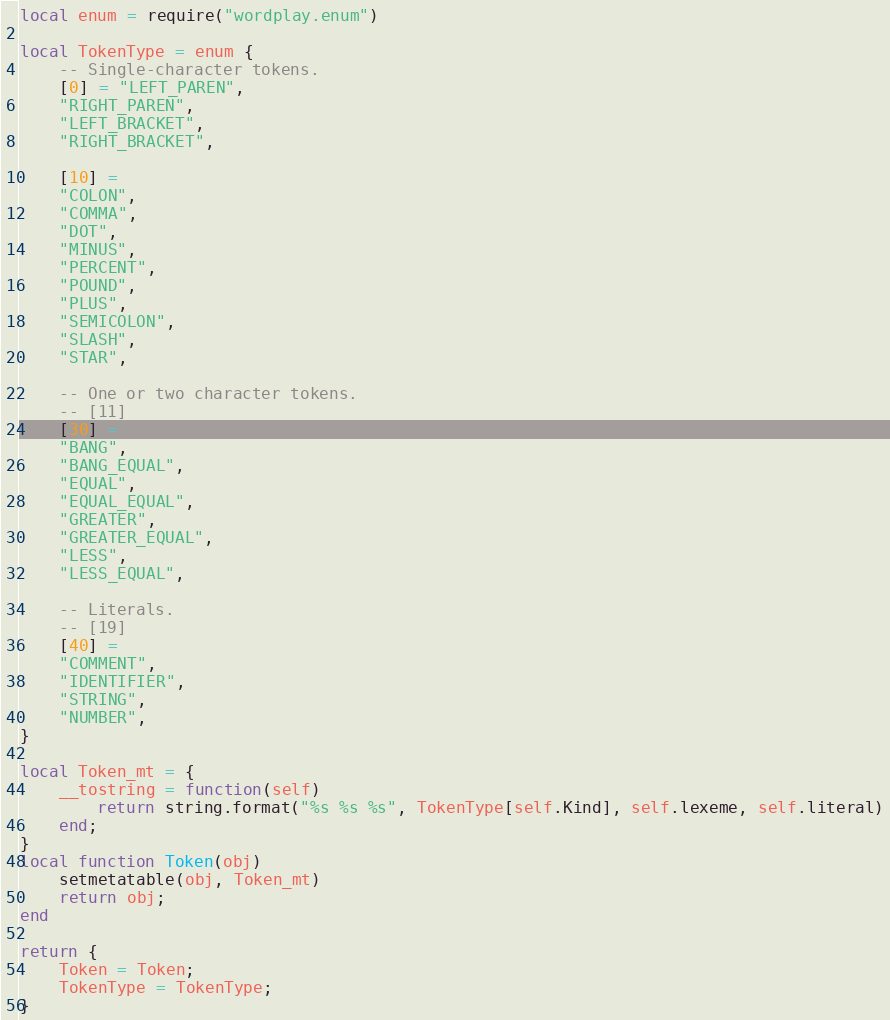Convert code to text. <code><loc_0><loc_0><loc_500><loc_500><_Lua_>local enum = require("wordplay.enum")

local TokenType = enum {                                   
    -- Single-character tokens.                      
    [0] = "LEFT_PAREN", 
    "RIGHT_PAREN", 
    "LEFT_BRACKET", 
    "RIGHT_BRACKET",
    
    [10] =
    "COLON",
    "COMMA", 
    "DOT", 
    "MINUS", 
    "PERCENT",
    "POUND",
    "PLUS", 
    "SEMICOLON", 
    "SLASH", 
    "STAR", 

    -- One or two character tokens.
    -- [11]
    [30] = 
    "BANG", 
    "BANG_EQUAL",                                
    "EQUAL", 
    "EQUAL_EQUAL",                              
    "GREATER", 
    "GREATER_EQUAL",                          
    "LESS", 
    "LESS_EQUAL",                                

    -- Literals.                                     
    -- [19]
    [40] =
    "COMMENT",
    "IDENTIFIER", 
    "STRING", 
    "NUMBER",   
}

local Token_mt = {
    __tostring = function(self)
        return string.format("%s %s %s", TokenType[self.Kind], self.lexeme, self.literal)
    end;
}
local function Token(obj)
    setmetatable(obj, Token_mt)
    return obj;
end

return {
    Token = Token;
    TokenType = TokenType;
}</code> 